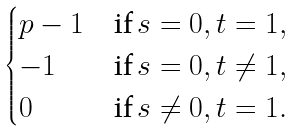Convert formula to latex. <formula><loc_0><loc_0><loc_500><loc_500>\begin{cases} p - 1 & \text {if} \, s = 0 , t = 1 , \\ - 1 & \text {if} \, s = 0 , t \neq 1 , \\ 0 & \text {if} \, s \neq 0 , t = 1 . \\ \end{cases}</formula> 